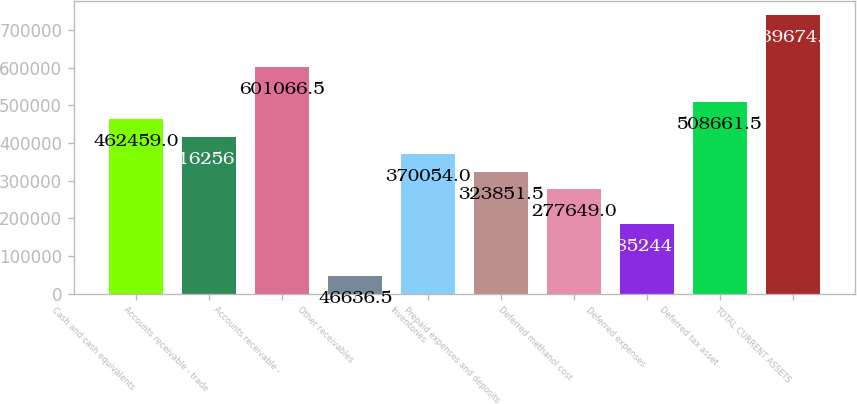<chart> <loc_0><loc_0><loc_500><loc_500><bar_chart><fcel>Cash and cash equivalents<fcel>Accounts receivable - trade<fcel>Accounts receivable -<fcel>Other receivables<fcel>Inventories<fcel>Prepaid expenses and deposits<fcel>Deferred methanol cost<fcel>Deferred expenses<fcel>Deferred tax asset<fcel>TOTAL CURRENT ASSETS<nl><fcel>462459<fcel>416256<fcel>601066<fcel>46636.5<fcel>370054<fcel>323852<fcel>277649<fcel>185244<fcel>508662<fcel>739674<nl></chart> 